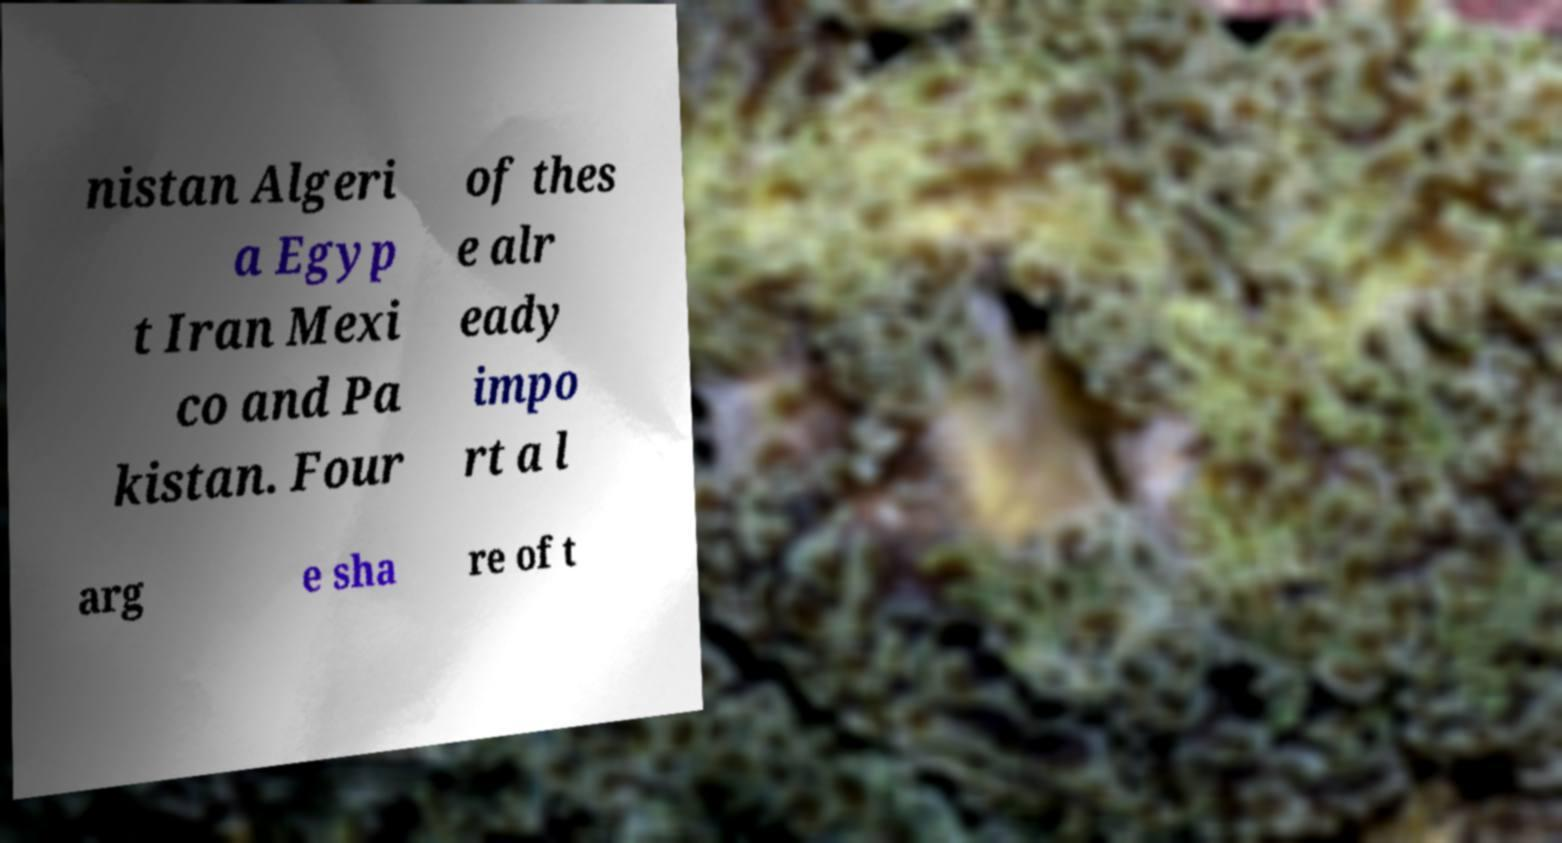Could you assist in decoding the text presented in this image and type it out clearly? nistan Algeri a Egyp t Iran Mexi co and Pa kistan. Four of thes e alr eady impo rt a l arg e sha re of t 